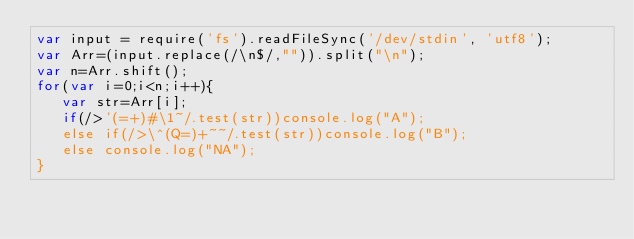<code> <loc_0><loc_0><loc_500><loc_500><_JavaScript_>var input = require('fs').readFileSync('/dev/stdin', 'utf8');
var Arr=(input.replace(/\n$/,"")).split("\n");
var n=Arr.shift();
for(var i=0;i<n;i++){
   var str=Arr[i];
   if(/>'(=+)#\1~/.test(str))console.log("A");
   else if(/>\^(Q=)+~~/.test(str))console.log("B");
   else console.log("NA");
}</code> 